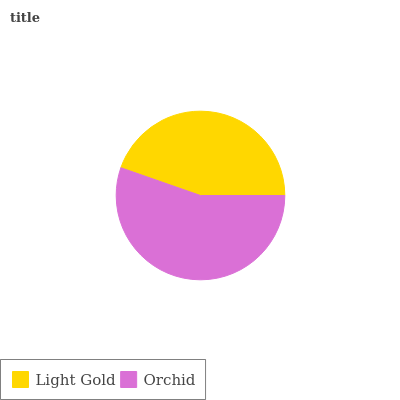Is Light Gold the minimum?
Answer yes or no. Yes. Is Orchid the maximum?
Answer yes or no. Yes. Is Orchid the minimum?
Answer yes or no. No. Is Orchid greater than Light Gold?
Answer yes or no. Yes. Is Light Gold less than Orchid?
Answer yes or no. Yes. Is Light Gold greater than Orchid?
Answer yes or no. No. Is Orchid less than Light Gold?
Answer yes or no. No. Is Orchid the high median?
Answer yes or no. Yes. Is Light Gold the low median?
Answer yes or no. Yes. Is Light Gold the high median?
Answer yes or no. No. Is Orchid the low median?
Answer yes or no. No. 